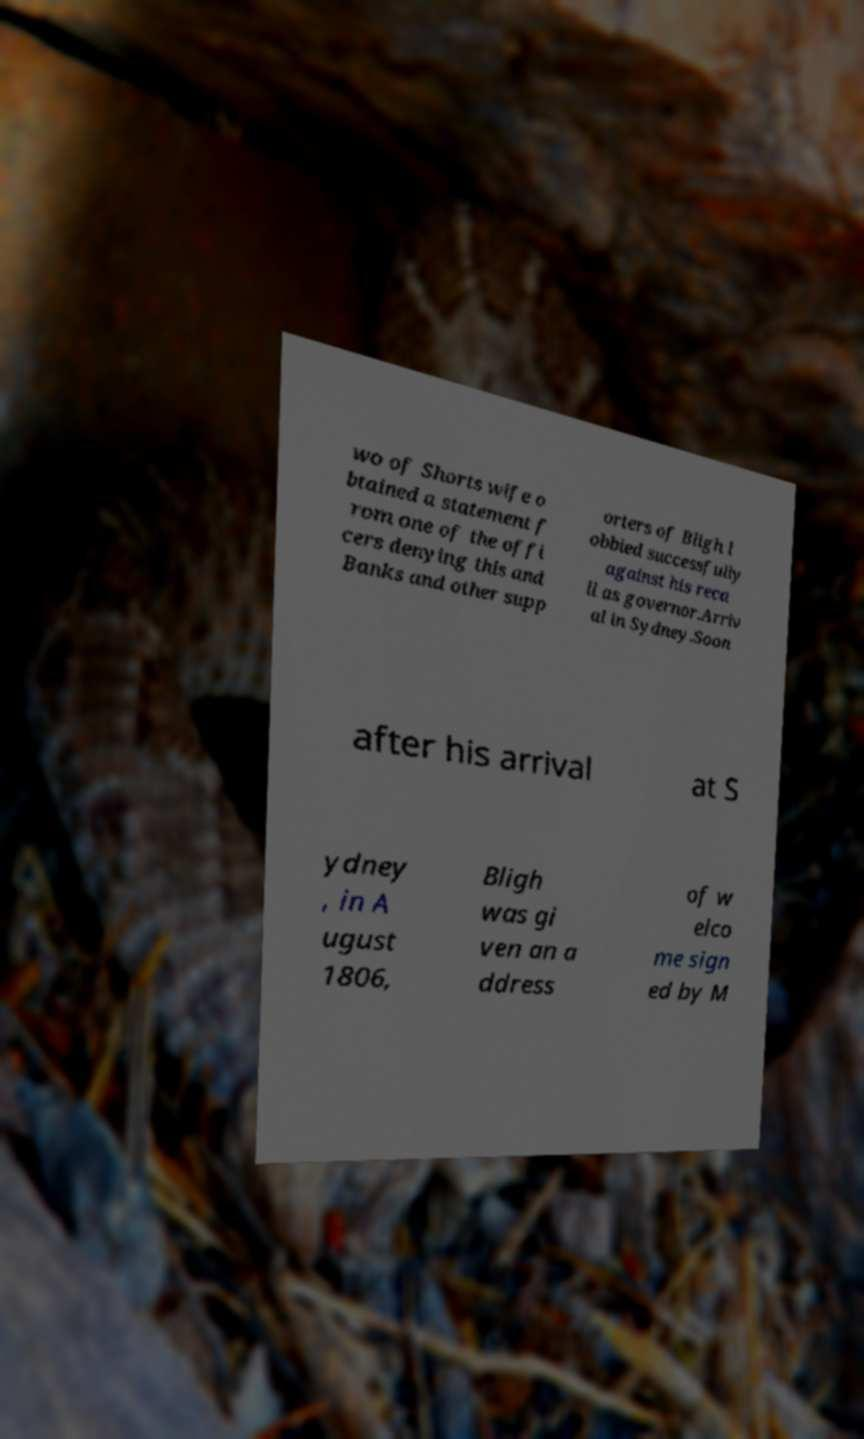I need the written content from this picture converted into text. Can you do that? wo of Shorts wife o btained a statement f rom one of the offi cers denying this and Banks and other supp orters of Bligh l obbied successfully against his reca ll as governor.Arriv al in Sydney.Soon after his arrival at S ydney , in A ugust 1806, Bligh was gi ven an a ddress of w elco me sign ed by M 